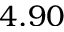<formula> <loc_0><loc_0><loc_500><loc_500>4 . 9 0</formula> 